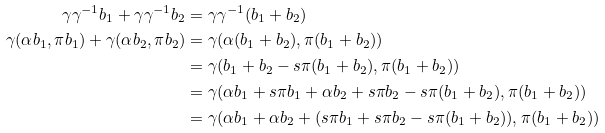<formula> <loc_0><loc_0><loc_500><loc_500>\gamma \gamma ^ { - 1 } b _ { 1 } + \gamma \gamma ^ { - 1 } b _ { 2 } & = \gamma \gamma ^ { - 1 } ( b _ { 1 } + b _ { 2 } ) \\ \gamma ( \alpha b _ { 1 } , \pi b _ { 1 } ) + \gamma ( \alpha b _ { 2 } , \pi b _ { 2 } ) & = \gamma ( \alpha ( b _ { 1 } + b _ { 2 } ) , \pi ( b _ { 1 } + b _ { 2 } ) ) \\ & = \gamma ( b _ { 1 } + b _ { 2 } - s \pi ( b _ { 1 } + b _ { 2 } ) , \pi ( b _ { 1 } + b _ { 2 } ) ) \\ & = \gamma ( \alpha b _ { 1 } + s \pi b _ { 1 } + \alpha b _ { 2 } + s \pi b _ { 2 } - s \pi ( b _ { 1 } + b _ { 2 } ) , \pi ( b _ { 1 } + b _ { 2 } ) ) \\ & = \gamma ( \alpha b _ { 1 } + \alpha b _ { 2 } + ( s \pi b _ { 1 } + s \pi b _ { 2 } - s \pi ( b _ { 1 } + b _ { 2 } ) ) , \pi ( b _ { 1 } + b _ { 2 } ) )</formula> 